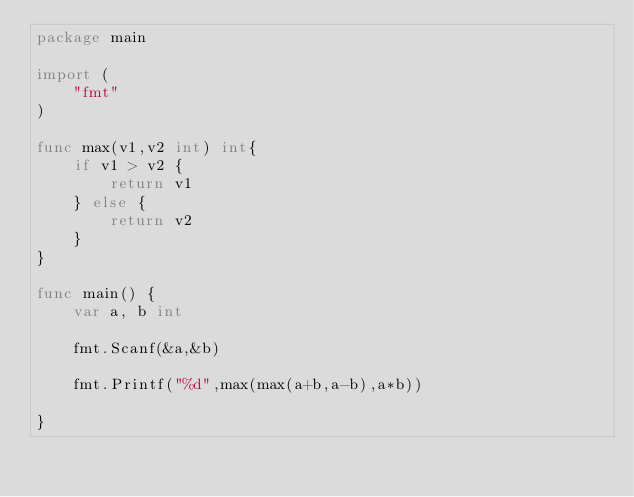<code> <loc_0><loc_0><loc_500><loc_500><_Go_>package main

import (
	"fmt"
)

func max(v1,v2 int) int{
	if v1 > v2 {
		return v1
	} else {
		return v2
	}
}

func main() {
	var a, b int
	
	fmt.Scanf(&a,&b)
	
	fmt.Printf("%d",max(max(a+b,a-b),a*b))

}</code> 